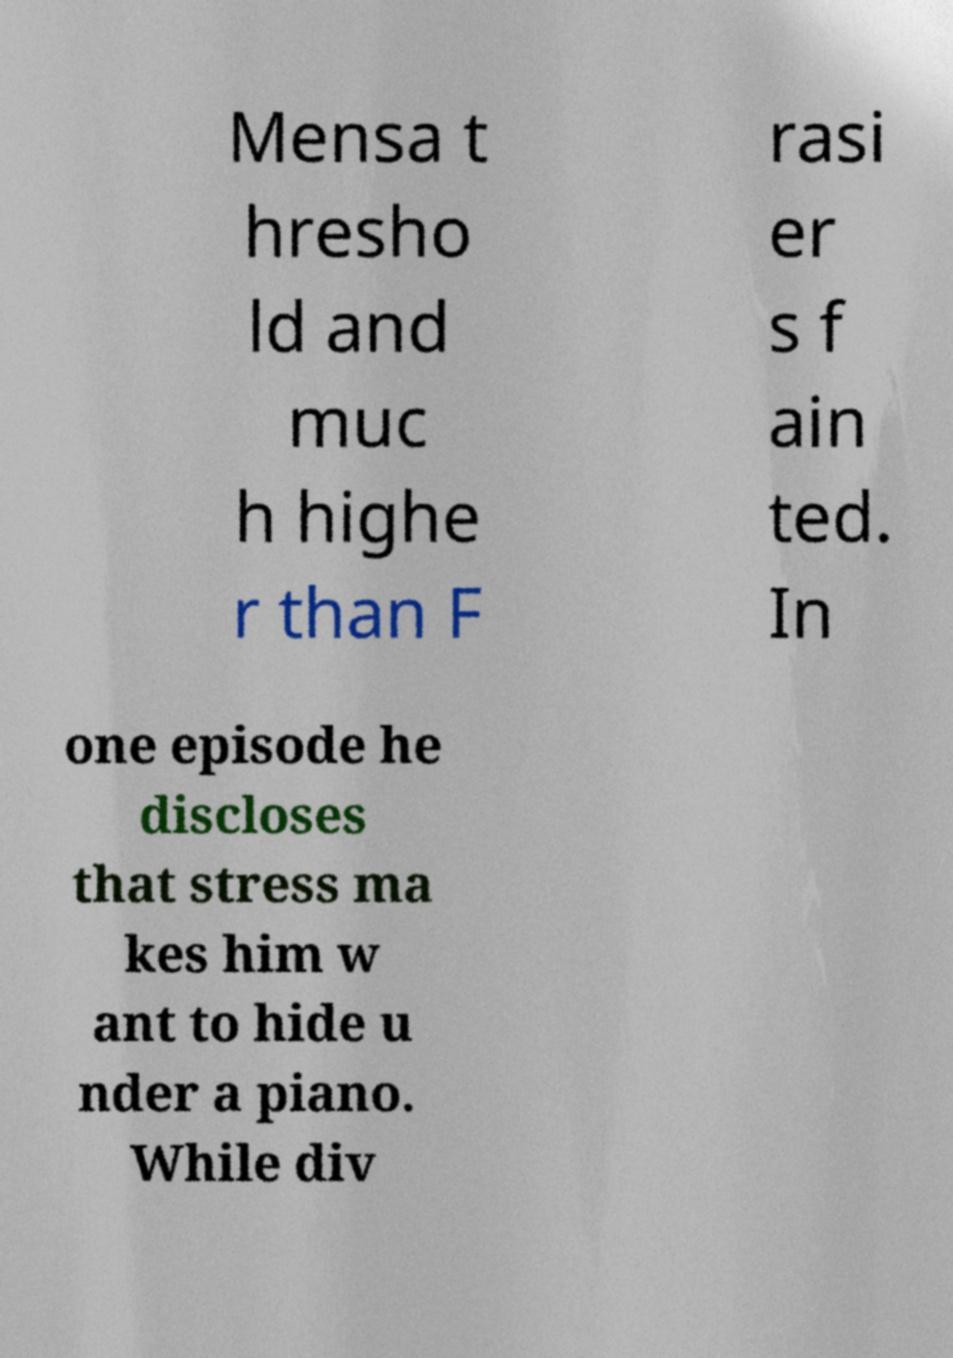Can you read and provide the text displayed in the image?This photo seems to have some interesting text. Can you extract and type it out for me? Mensa t hresho ld and muc h highe r than F rasi er s f ain ted. In one episode he discloses that stress ma kes him w ant to hide u nder a piano. While div 